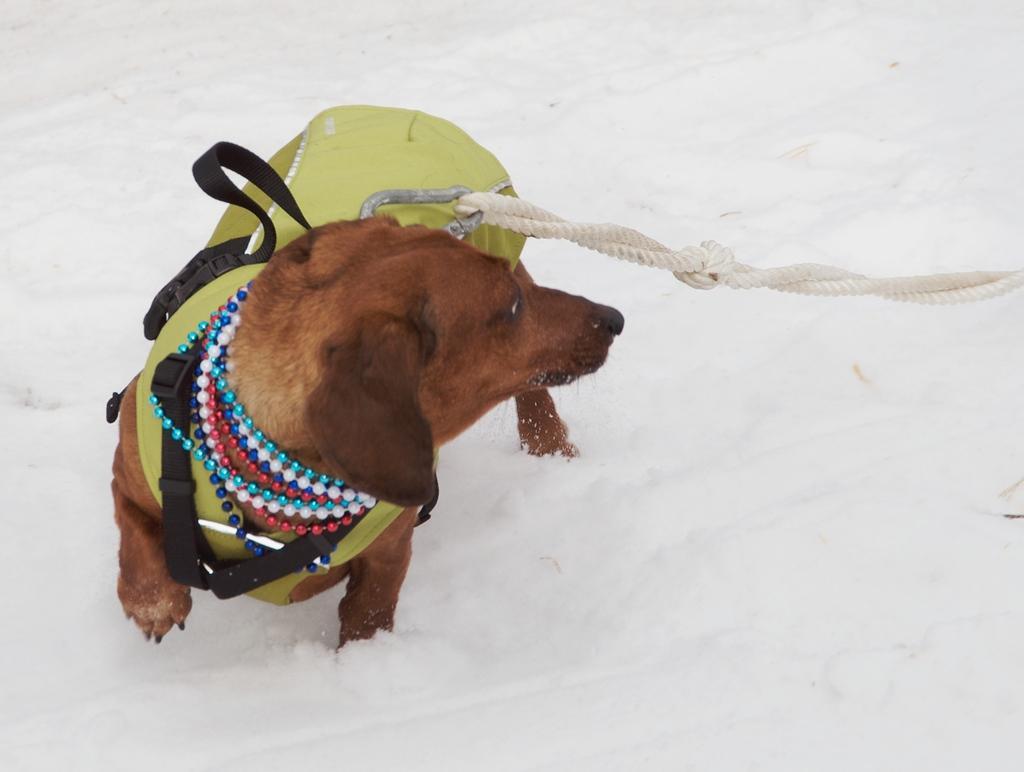In one or two sentences, can you explain what this image depicts? In this image there is a dog with a hook and a rope. 